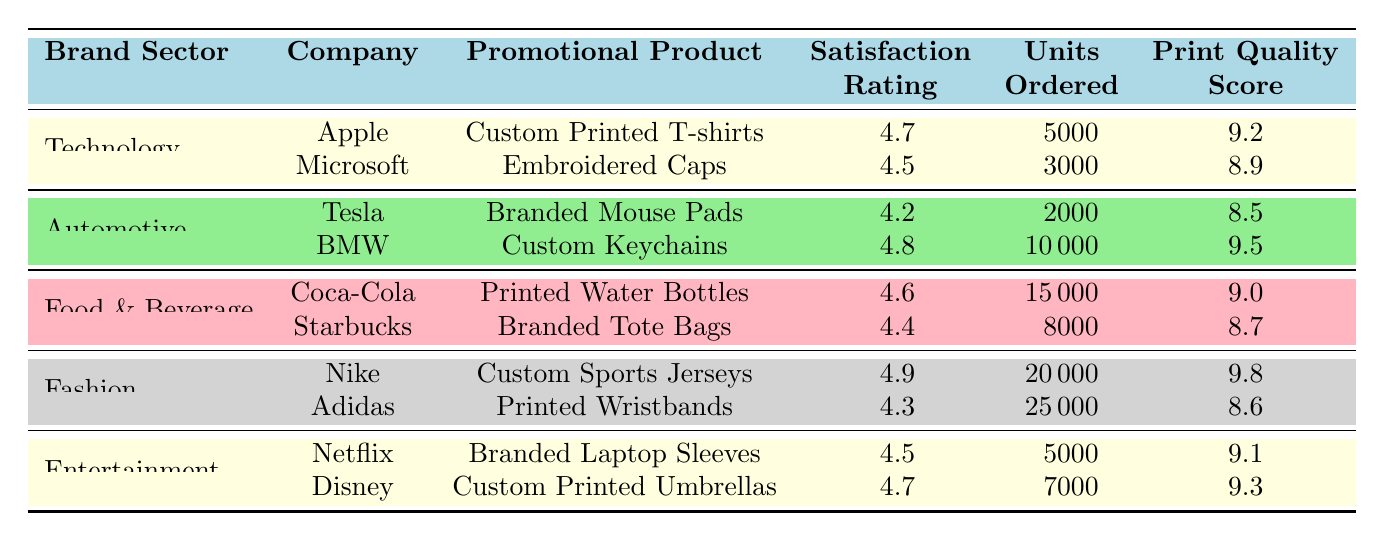What is the satisfaction rating of Apple's custom printed T-shirts? The table shows that Apple's custom printed T-shirts have a satisfaction rating of 4.7. This information can be found directly in the corresponding row for Apple under the Technology brand sector.
Answer: 4.7 Which promotional product has the highest Print Quality Score? By examining the Print Quality Score column, Nike's Custom Sports Jerseys have the highest score of 9.8. This is evident as it is the highest number listed in that column.
Answer: 9.8 How many units of Adidas' printed wristbands were ordered? The table indicates that Adidas' printed wristbands had 25,000 units ordered, as seen in the corresponding row for Adidas under the Fashion brand sector.
Answer: 25000 What is the average satisfaction rating for promotional products in the Food & Beverage sector? The satisfaction ratings for Coca-Cola and Starbucks are 4.6 and 4.4, respectively. To find the average, add these values (4.6 + 4.4 = 9.0) and divide by 2, resulting in an average of 4.5.
Answer: 4.5 Is the satisfaction rating for Tesla's branded mouse pads higher than that of Microsoft's embroidered caps? The satisfaction rating for Tesla is 4.2 and for Microsoft is 4.5. Since 4.2 is less than 4.5, the statement is false.
Answer: No How many more units were ordered for Nike's custom sports jerseys compared to Coca-Cola's printed water bottles? Nike's custom sports jerseys had 20,000 units ordered while Coca-Cola's printed water bottles had 15,000 units. The difference is 20,000 - 15,000 = 5,000 units.
Answer: 5000 Which brand sector had the highest average satisfaction rating among its promotional products? The satisfaction ratings for each sector are Technology (4.6), Automotive (4.5), Food & Beverage (4.5), Fashion (4.6), and Entertainment (4.6). The Technology sector has the highest average of 4.6, calculated by averaging 4.7 and 4.5.
Answer: Technology Are Starbuck's branded tote bags more favored than Tesla's branded mouse pads in terms of satisfaction rating? Starbucks has a satisfaction rating of 4.4 while Tesla has a rating of 4.2. Therefore, since 4.4 is greater than 4.2, it is true that Starbucks' branded tote bags are more favored.
Answer: Yes What is the total number of units ordered across all promotional products? The total units ordered can be calculated by summing the units for each product: 5000 + 3000 + 2000 + 10000 + 15000 + 8000 + 20000 + 25000 + 5000 + 7000 = 105000.
Answer: 105000 